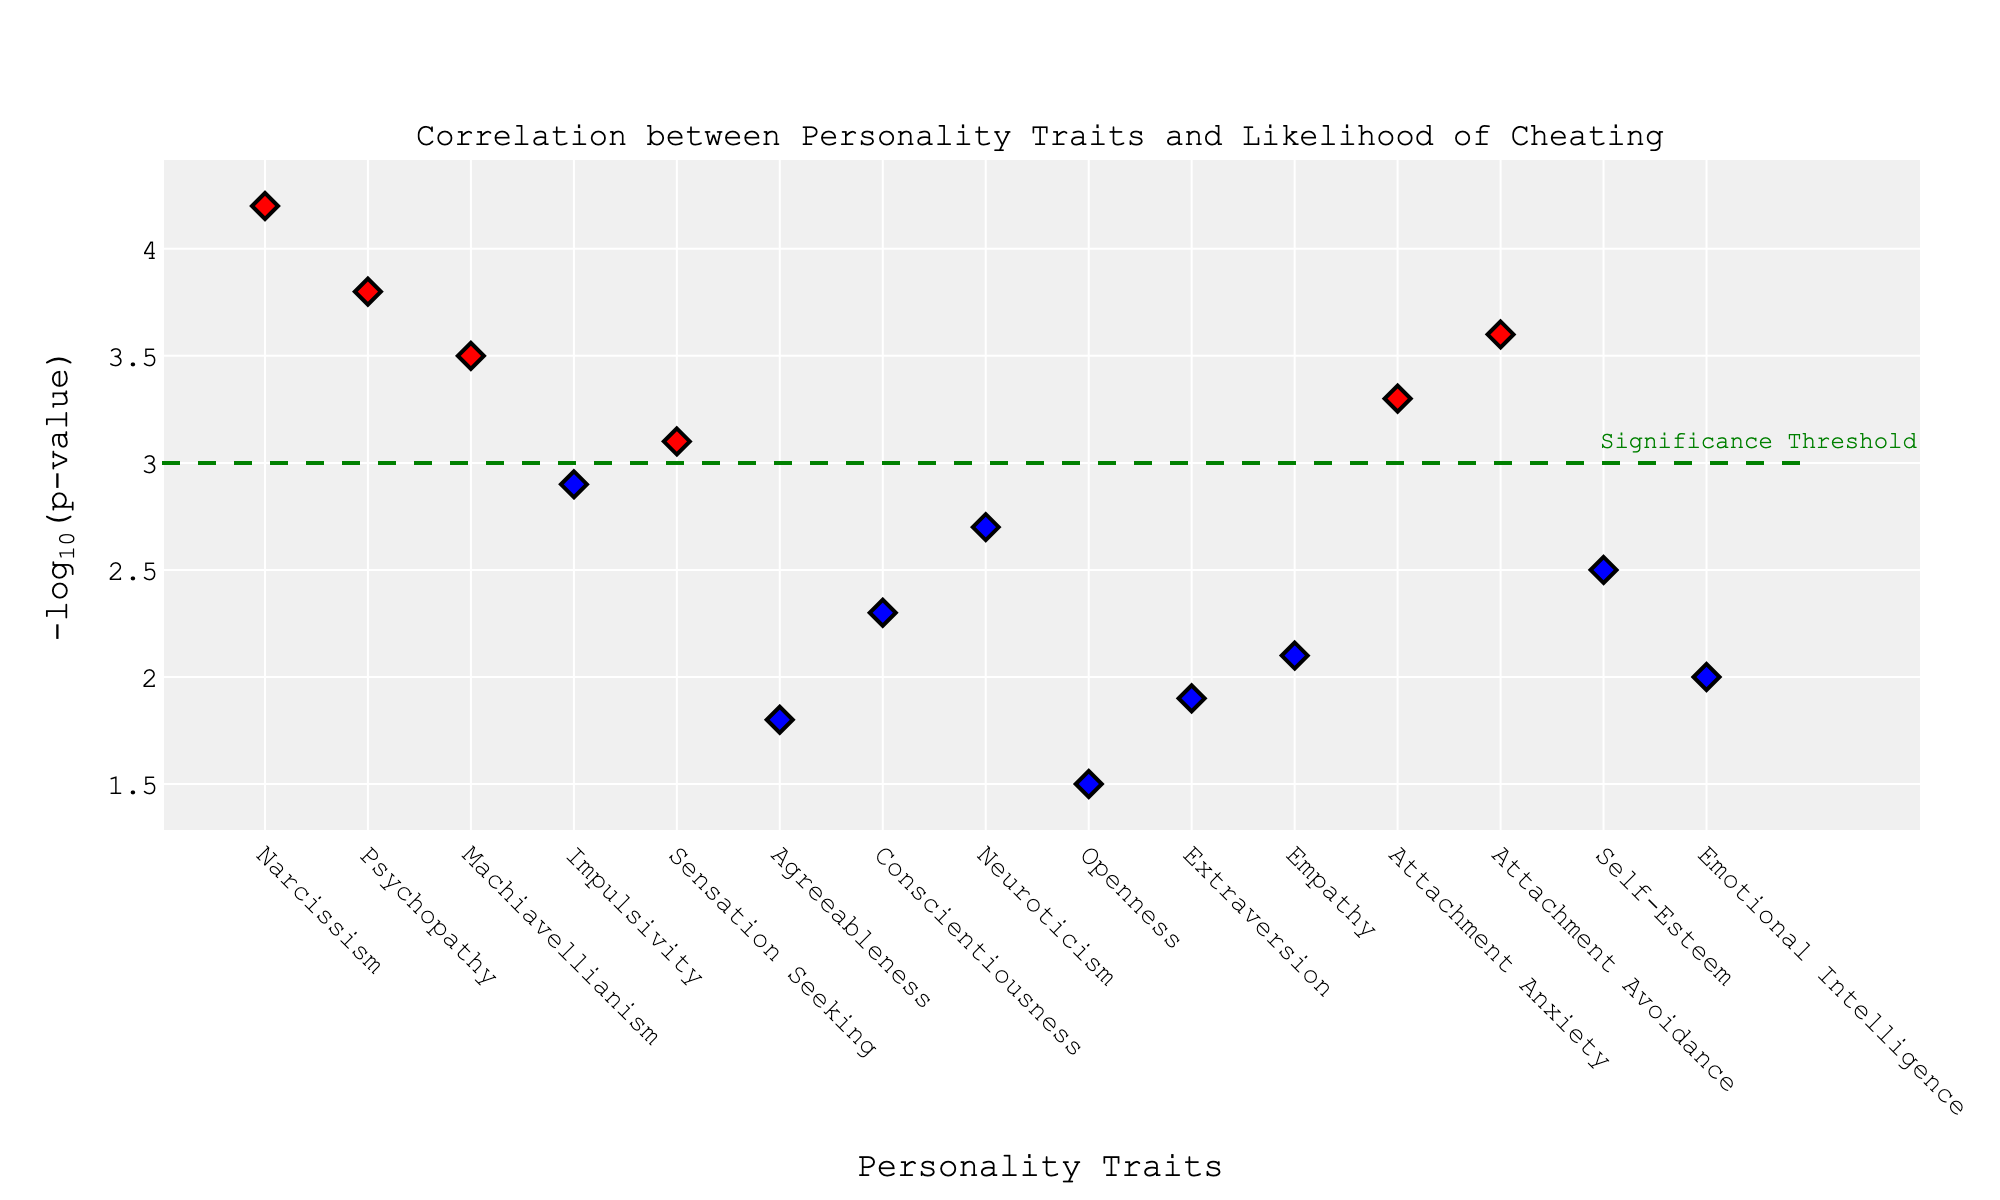What is the title of the plot? The title of the plot is displayed at the top of the figure. It says "Correlation between Personality Traits and Likelihood of Cheating."
Answer: Correlation between Personality Traits and Likelihood of Cheating How many personality traits are analyzed in the plot? Count the number of distinct points shown on the x-axis. There are 15 unique data points each representing a different personality trait.
Answer: 15 Which personality trait has the highest -log(p-value)? Look for the point at the highest position on the y-axis. Narcissism has the highest -log(p-value) with a value of 4.2.
Answer: Narcissism Which traits are marked in red? Red markers indicate traits with -log(p-value) ≥ 3. These traits are Narcissism, Psychopathy, Machiavellianism, Attachment Avoidance, and Attachment Anxiety.
Answer: Narcissism, Psychopathy, Machiavellianism, Attachment Avoidance, Attachment Anxiety How many traits are above the significance threshold? Count the number of points that are above the green significance threshold line at y=3. There are 5 traits above the threshold.
Answer: 5 What is the -log(p-value) of Conscientiousness and how does it compare to the threshold? Find the -log(p-value) of Conscientiousness on the y-axis; it’s 2.3, which is below the significance threshold of 3.
Answer: 2.3, below the threshold Which trait associated with the NEO-PI-R scale has the lowest -log(p-value)? Compare the -log(p-values) of the traits from the NEO-PI-R scale: Agreeableness (1.8), Conscientiousness (2.3), Neuroticism (2.7), Openness (1.5), Extraversion (1.9). The lowest is Openness with 1.5.
Answer: Openness What is the difference in -log(p-value) between Psychopathy and Sensation Seeking? Subtract the -log(p-value) of Sensation Seeking (3.1) from Psychopathy (3.8). The difference is 3.8 - 3.1 = 0.7.
Answer: 0.7 Which traits from the EQ and MSCEIT scales are plotted, and what are their -log(p-values)? The EQ scale trait is Empathy with -log(p-value) of 2.1. The MSCEIT scale trait is Emotional Intelligence with -log(p-value) of 2.0.
Answer: Empathy: 2.1, Emotional Intelligence: 2.0 What is the average -log(p-value) of the top 3 traits? The top 3 traits are Narcissism (4.2), Psychopathy (3.8), and Machiavellianism (3.5). Calculate the average: (4.2 + 3.8 + 3.5) / 3 = 3.83
Answer: 3.83 